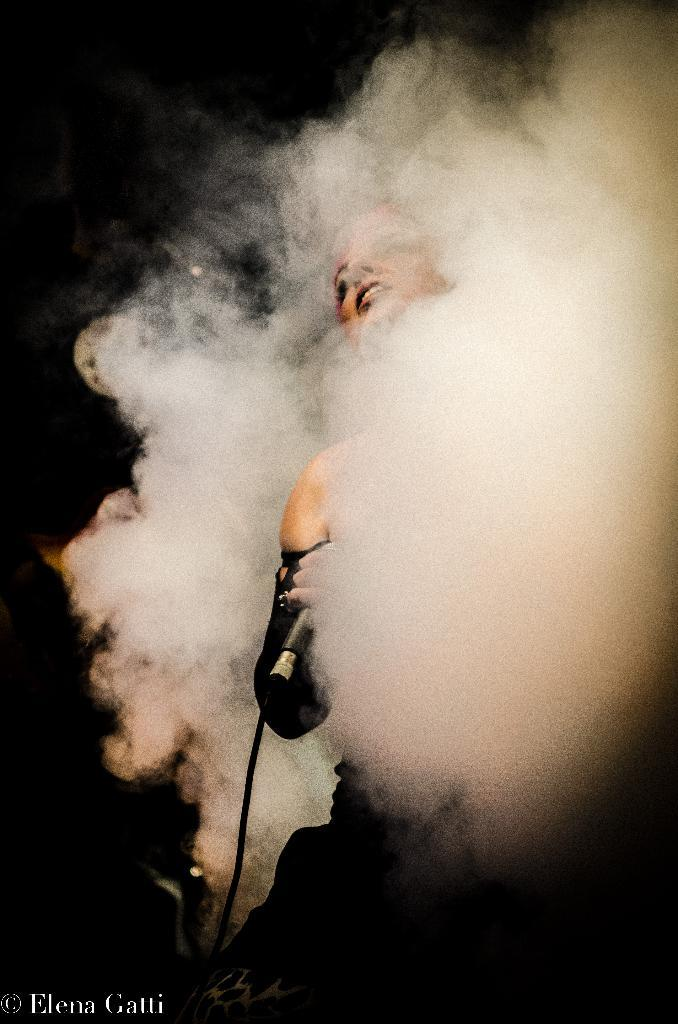What is the person in the image holding? The person is holding a mic. What can be seen around the person in the image? There is smoke visible around the person. What is the color of the background in the image? The background of the image is dark. What is the condition of the jelly in the image? There is no jelly present in the image. Can you describe the man in the image? The facts provided do not mention the gender of the person, so we cannot definitively say if the person is a man or a woman. 